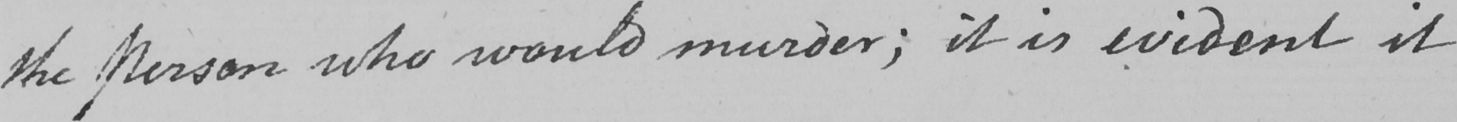Please transcribe the handwritten text in this image. the Person who would murder ; it is evident it 